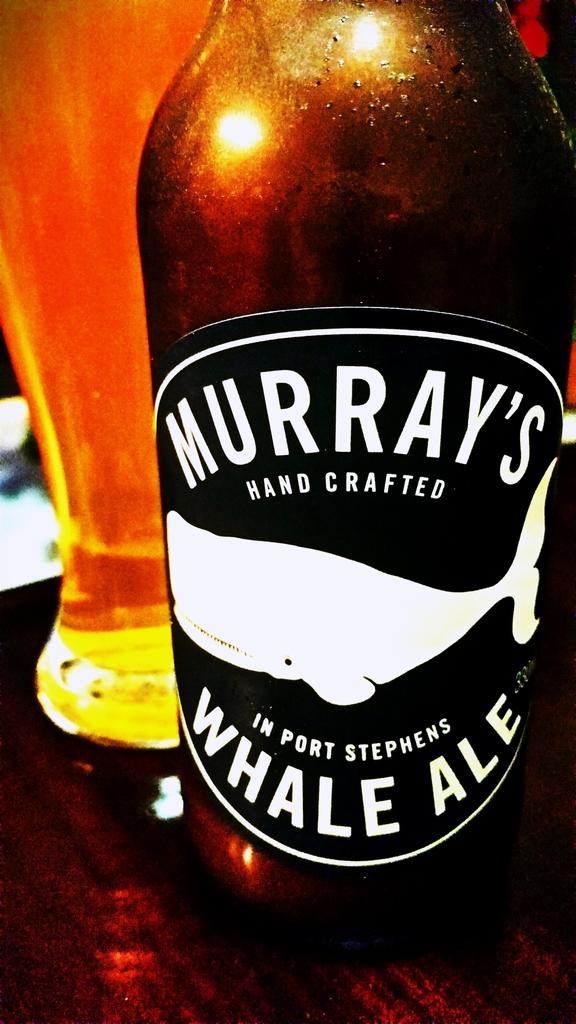What is hand crafted?
Keep it short and to the point. Whale ale. Where is whale ale made?
Provide a succinct answer. Port stephens. 